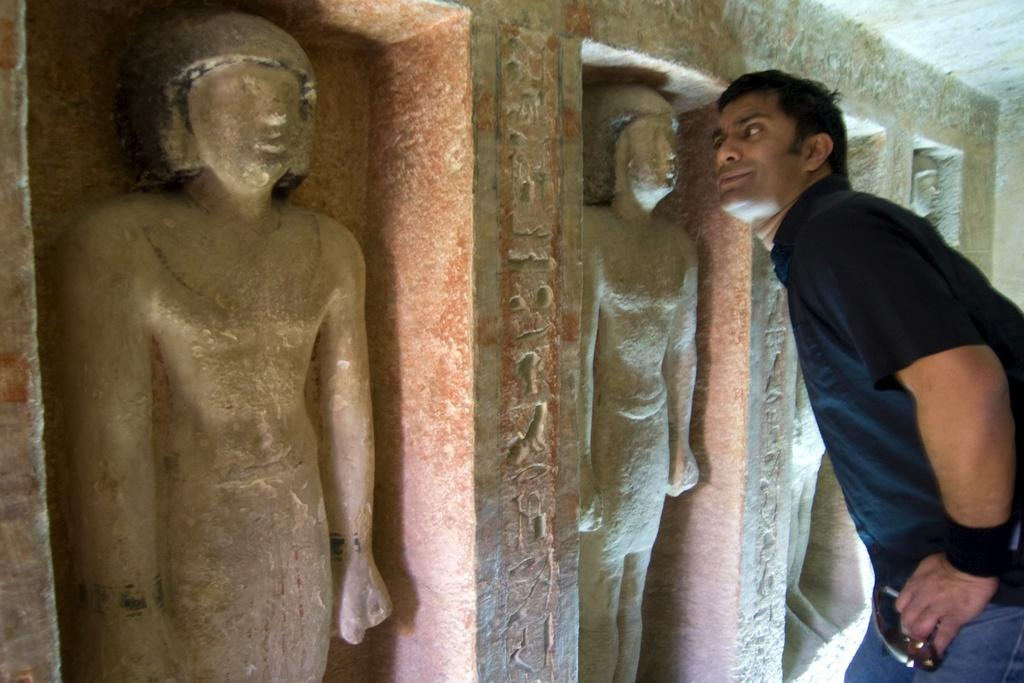What type of artwork can be seen in the image? There are sculptures in the image. Can you describe the man's position in relation to the sculptures? A man is standing beside the sculptures. What type of basketball show is taking place in the image? There is no basketball show present in the image; it features sculptures and a man standing beside them. 